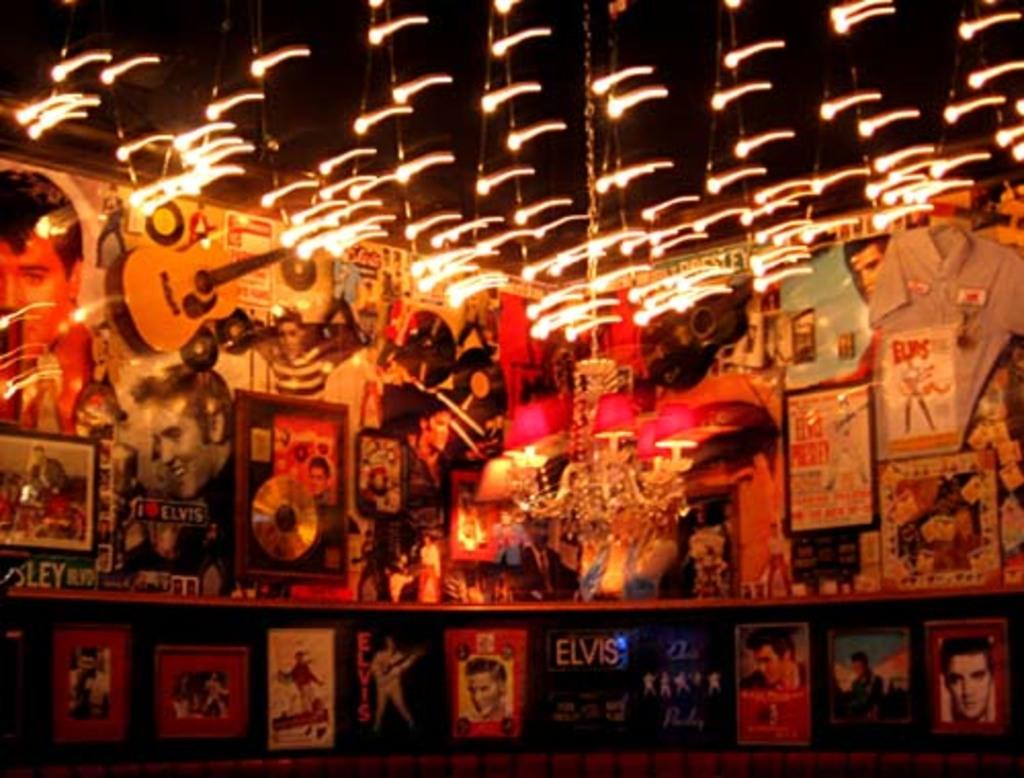What is visible at the top of the image? There are lights visible in the image, and they are at the top of the image. What can be seen in the middle of the image? There are different photographs in the middle of the image. Can you see a tramp in the image? There is no tramp present in the image. Are there any crackers or fish visible in the image? There are no crackers or fish present in the image. 